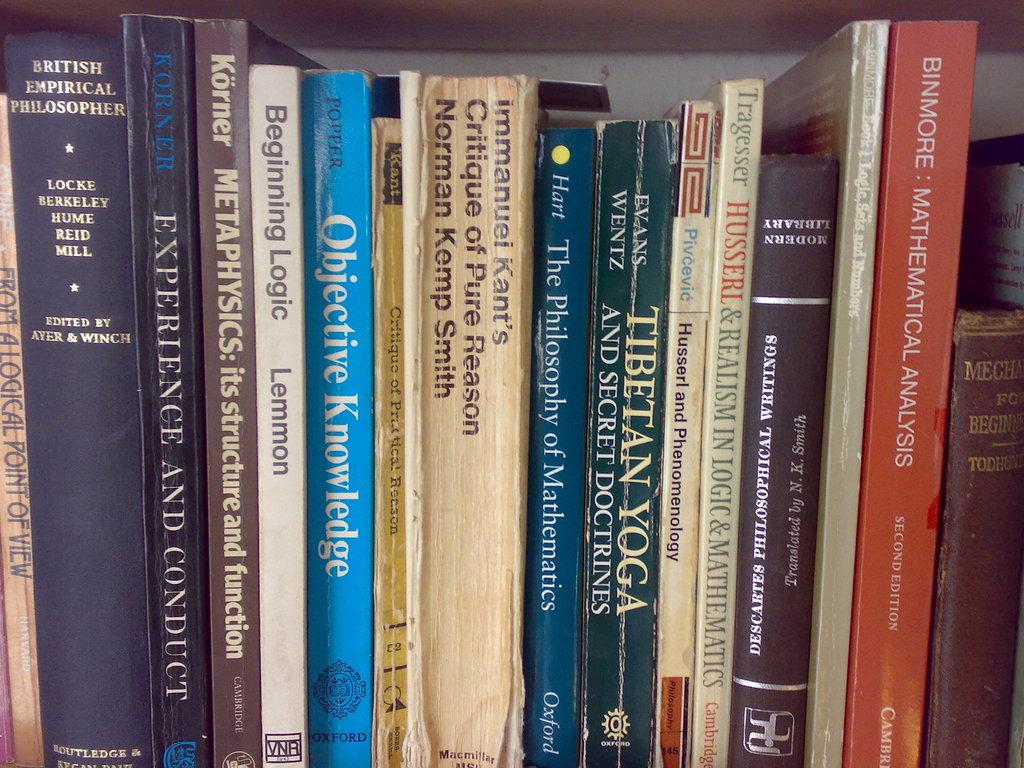Who wrote beginning logic?
Offer a terse response. Lemmon. 